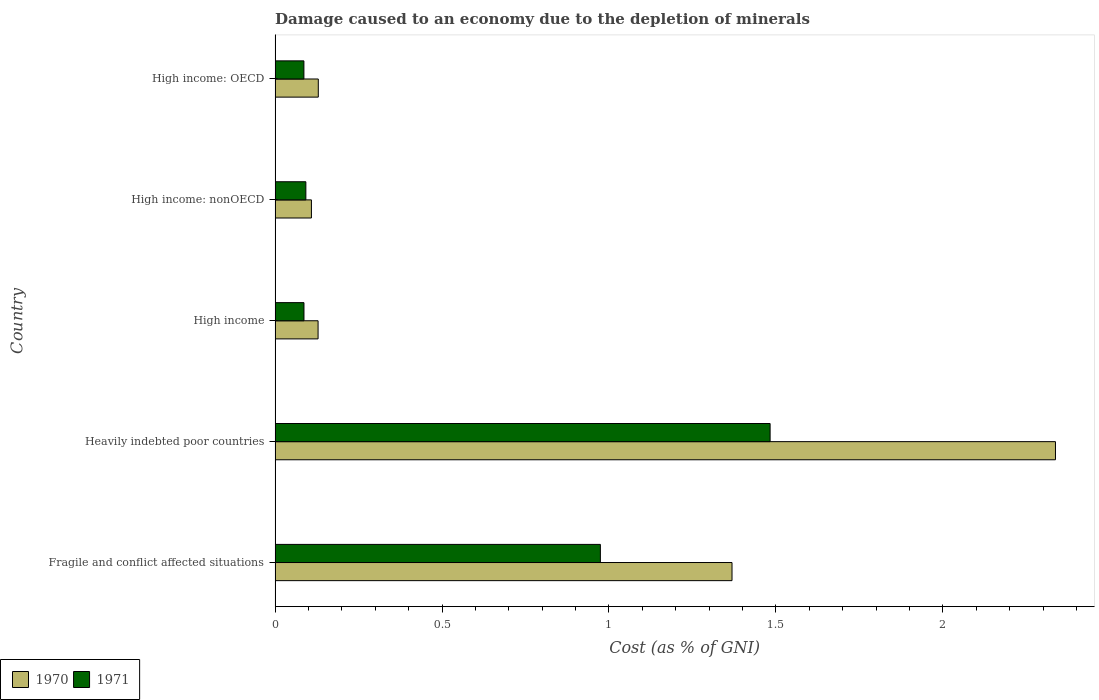How many groups of bars are there?
Provide a short and direct response. 5. Are the number of bars per tick equal to the number of legend labels?
Keep it short and to the point. Yes. Are the number of bars on each tick of the Y-axis equal?
Your answer should be very brief. Yes. How many bars are there on the 1st tick from the bottom?
Your answer should be compact. 2. What is the cost of damage caused due to the depletion of minerals in 1971 in High income: OECD?
Provide a short and direct response. 0.09. Across all countries, what is the maximum cost of damage caused due to the depletion of minerals in 1970?
Provide a short and direct response. 2.34. Across all countries, what is the minimum cost of damage caused due to the depletion of minerals in 1970?
Offer a terse response. 0.11. In which country was the cost of damage caused due to the depletion of minerals in 1971 maximum?
Offer a very short reply. Heavily indebted poor countries. In which country was the cost of damage caused due to the depletion of minerals in 1970 minimum?
Offer a terse response. High income: nonOECD. What is the total cost of damage caused due to the depletion of minerals in 1971 in the graph?
Make the answer very short. 2.72. What is the difference between the cost of damage caused due to the depletion of minerals in 1971 in Heavily indebted poor countries and that in High income: nonOECD?
Offer a very short reply. 1.39. What is the difference between the cost of damage caused due to the depletion of minerals in 1970 in High income: nonOECD and the cost of damage caused due to the depletion of minerals in 1971 in High income: OECD?
Provide a succinct answer. 0.02. What is the average cost of damage caused due to the depletion of minerals in 1971 per country?
Make the answer very short. 0.54. What is the difference between the cost of damage caused due to the depletion of minerals in 1971 and cost of damage caused due to the depletion of minerals in 1970 in High income: OECD?
Your response must be concise. -0.04. In how many countries, is the cost of damage caused due to the depletion of minerals in 1970 greater than 1.3 %?
Provide a short and direct response. 2. What is the ratio of the cost of damage caused due to the depletion of minerals in 1970 in Fragile and conflict affected situations to that in High income?
Your response must be concise. 10.63. Is the cost of damage caused due to the depletion of minerals in 1970 in High income less than that in High income: OECD?
Your answer should be very brief. Yes. What is the difference between the highest and the second highest cost of damage caused due to the depletion of minerals in 1970?
Give a very brief answer. 0.97. What is the difference between the highest and the lowest cost of damage caused due to the depletion of minerals in 1971?
Your answer should be very brief. 1.4. In how many countries, is the cost of damage caused due to the depletion of minerals in 1971 greater than the average cost of damage caused due to the depletion of minerals in 1971 taken over all countries?
Give a very brief answer. 2. Is the sum of the cost of damage caused due to the depletion of minerals in 1971 in Fragile and conflict affected situations and High income greater than the maximum cost of damage caused due to the depletion of minerals in 1970 across all countries?
Provide a succinct answer. No. Are all the bars in the graph horizontal?
Your response must be concise. Yes. What is the difference between two consecutive major ticks on the X-axis?
Give a very brief answer. 0.5. Are the values on the major ticks of X-axis written in scientific E-notation?
Keep it short and to the point. No. Does the graph contain grids?
Your answer should be compact. No. How are the legend labels stacked?
Keep it short and to the point. Horizontal. What is the title of the graph?
Offer a terse response. Damage caused to an economy due to the depletion of minerals. What is the label or title of the X-axis?
Ensure brevity in your answer.  Cost (as % of GNI). What is the Cost (as % of GNI) of 1970 in Fragile and conflict affected situations?
Offer a very short reply. 1.37. What is the Cost (as % of GNI) in 1971 in Fragile and conflict affected situations?
Your answer should be compact. 0.97. What is the Cost (as % of GNI) of 1970 in Heavily indebted poor countries?
Your answer should be compact. 2.34. What is the Cost (as % of GNI) in 1971 in Heavily indebted poor countries?
Give a very brief answer. 1.48. What is the Cost (as % of GNI) in 1970 in High income?
Your answer should be very brief. 0.13. What is the Cost (as % of GNI) of 1971 in High income?
Keep it short and to the point. 0.09. What is the Cost (as % of GNI) of 1970 in High income: nonOECD?
Provide a succinct answer. 0.11. What is the Cost (as % of GNI) of 1971 in High income: nonOECD?
Offer a terse response. 0.09. What is the Cost (as % of GNI) in 1970 in High income: OECD?
Provide a succinct answer. 0.13. What is the Cost (as % of GNI) of 1971 in High income: OECD?
Provide a succinct answer. 0.09. Across all countries, what is the maximum Cost (as % of GNI) of 1970?
Provide a succinct answer. 2.34. Across all countries, what is the maximum Cost (as % of GNI) of 1971?
Your answer should be very brief. 1.48. Across all countries, what is the minimum Cost (as % of GNI) of 1970?
Your response must be concise. 0.11. Across all countries, what is the minimum Cost (as % of GNI) in 1971?
Provide a short and direct response. 0.09. What is the total Cost (as % of GNI) of 1970 in the graph?
Provide a short and direct response. 4.07. What is the total Cost (as % of GNI) in 1971 in the graph?
Your answer should be very brief. 2.72. What is the difference between the Cost (as % of GNI) in 1970 in Fragile and conflict affected situations and that in Heavily indebted poor countries?
Offer a terse response. -0.97. What is the difference between the Cost (as % of GNI) of 1971 in Fragile and conflict affected situations and that in Heavily indebted poor countries?
Offer a terse response. -0.51. What is the difference between the Cost (as % of GNI) of 1970 in Fragile and conflict affected situations and that in High income?
Make the answer very short. 1.24. What is the difference between the Cost (as % of GNI) of 1971 in Fragile and conflict affected situations and that in High income?
Offer a very short reply. 0.89. What is the difference between the Cost (as % of GNI) in 1970 in Fragile and conflict affected situations and that in High income: nonOECD?
Ensure brevity in your answer.  1.26. What is the difference between the Cost (as % of GNI) in 1971 in Fragile and conflict affected situations and that in High income: nonOECD?
Ensure brevity in your answer.  0.88. What is the difference between the Cost (as % of GNI) in 1970 in Fragile and conflict affected situations and that in High income: OECD?
Keep it short and to the point. 1.24. What is the difference between the Cost (as % of GNI) in 1971 in Fragile and conflict affected situations and that in High income: OECD?
Give a very brief answer. 0.89. What is the difference between the Cost (as % of GNI) in 1970 in Heavily indebted poor countries and that in High income?
Provide a short and direct response. 2.21. What is the difference between the Cost (as % of GNI) of 1971 in Heavily indebted poor countries and that in High income?
Your response must be concise. 1.4. What is the difference between the Cost (as % of GNI) in 1970 in Heavily indebted poor countries and that in High income: nonOECD?
Your answer should be compact. 2.23. What is the difference between the Cost (as % of GNI) in 1971 in Heavily indebted poor countries and that in High income: nonOECD?
Keep it short and to the point. 1.39. What is the difference between the Cost (as % of GNI) in 1970 in Heavily indebted poor countries and that in High income: OECD?
Offer a terse response. 2.21. What is the difference between the Cost (as % of GNI) of 1971 in Heavily indebted poor countries and that in High income: OECD?
Your answer should be very brief. 1.4. What is the difference between the Cost (as % of GNI) of 1971 in High income and that in High income: nonOECD?
Offer a terse response. -0.01. What is the difference between the Cost (as % of GNI) in 1970 in High income and that in High income: OECD?
Your response must be concise. -0. What is the difference between the Cost (as % of GNI) of 1970 in High income: nonOECD and that in High income: OECD?
Give a very brief answer. -0.02. What is the difference between the Cost (as % of GNI) of 1971 in High income: nonOECD and that in High income: OECD?
Give a very brief answer. 0.01. What is the difference between the Cost (as % of GNI) in 1970 in Fragile and conflict affected situations and the Cost (as % of GNI) in 1971 in Heavily indebted poor countries?
Keep it short and to the point. -0.11. What is the difference between the Cost (as % of GNI) in 1970 in Fragile and conflict affected situations and the Cost (as % of GNI) in 1971 in High income?
Provide a short and direct response. 1.28. What is the difference between the Cost (as % of GNI) of 1970 in Fragile and conflict affected situations and the Cost (as % of GNI) of 1971 in High income: nonOECD?
Ensure brevity in your answer.  1.28. What is the difference between the Cost (as % of GNI) in 1970 in Fragile and conflict affected situations and the Cost (as % of GNI) in 1971 in High income: OECD?
Make the answer very short. 1.28. What is the difference between the Cost (as % of GNI) of 1970 in Heavily indebted poor countries and the Cost (as % of GNI) of 1971 in High income?
Your response must be concise. 2.25. What is the difference between the Cost (as % of GNI) of 1970 in Heavily indebted poor countries and the Cost (as % of GNI) of 1971 in High income: nonOECD?
Ensure brevity in your answer.  2.25. What is the difference between the Cost (as % of GNI) of 1970 in Heavily indebted poor countries and the Cost (as % of GNI) of 1971 in High income: OECD?
Provide a succinct answer. 2.25. What is the difference between the Cost (as % of GNI) of 1970 in High income and the Cost (as % of GNI) of 1971 in High income: nonOECD?
Keep it short and to the point. 0.04. What is the difference between the Cost (as % of GNI) in 1970 in High income and the Cost (as % of GNI) in 1971 in High income: OECD?
Your answer should be compact. 0.04. What is the difference between the Cost (as % of GNI) in 1970 in High income: nonOECD and the Cost (as % of GNI) in 1971 in High income: OECD?
Give a very brief answer. 0.02. What is the average Cost (as % of GNI) of 1970 per country?
Your answer should be compact. 0.81. What is the average Cost (as % of GNI) of 1971 per country?
Keep it short and to the point. 0.54. What is the difference between the Cost (as % of GNI) in 1970 and Cost (as % of GNI) in 1971 in Fragile and conflict affected situations?
Provide a succinct answer. 0.39. What is the difference between the Cost (as % of GNI) of 1970 and Cost (as % of GNI) of 1971 in Heavily indebted poor countries?
Keep it short and to the point. 0.85. What is the difference between the Cost (as % of GNI) of 1970 and Cost (as % of GNI) of 1971 in High income?
Give a very brief answer. 0.04. What is the difference between the Cost (as % of GNI) of 1970 and Cost (as % of GNI) of 1971 in High income: nonOECD?
Give a very brief answer. 0.02. What is the difference between the Cost (as % of GNI) of 1970 and Cost (as % of GNI) of 1971 in High income: OECD?
Ensure brevity in your answer.  0.04. What is the ratio of the Cost (as % of GNI) of 1970 in Fragile and conflict affected situations to that in Heavily indebted poor countries?
Your response must be concise. 0.59. What is the ratio of the Cost (as % of GNI) in 1971 in Fragile and conflict affected situations to that in Heavily indebted poor countries?
Offer a terse response. 0.66. What is the ratio of the Cost (as % of GNI) in 1970 in Fragile and conflict affected situations to that in High income?
Your answer should be very brief. 10.63. What is the ratio of the Cost (as % of GNI) in 1971 in Fragile and conflict affected situations to that in High income?
Ensure brevity in your answer.  11.26. What is the ratio of the Cost (as % of GNI) in 1970 in Fragile and conflict affected situations to that in High income: nonOECD?
Provide a short and direct response. 12.57. What is the ratio of the Cost (as % of GNI) of 1971 in Fragile and conflict affected situations to that in High income: nonOECD?
Your answer should be very brief. 10.57. What is the ratio of the Cost (as % of GNI) of 1970 in Fragile and conflict affected situations to that in High income: OECD?
Provide a short and direct response. 10.57. What is the ratio of the Cost (as % of GNI) of 1971 in Fragile and conflict affected situations to that in High income: OECD?
Give a very brief answer. 11.28. What is the ratio of the Cost (as % of GNI) in 1970 in Heavily indebted poor countries to that in High income?
Your response must be concise. 18.15. What is the ratio of the Cost (as % of GNI) of 1971 in Heavily indebted poor countries to that in High income?
Make the answer very short. 17.13. What is the ratio of the Cost (as % of GNI) of 1970 in Heavily indebted poor countries to that in High income: nonOECD?
Give a very brief answer. 21.48. What is the ratio of the Cost (as % of GNI) in 1971 in Heavily indebted poor countries to that in High income: nonOECD?
Provide a short and direct response. 16.08. What is the ratio of the Cost (as % of GNI) in 1970 in Heavily indebted poor countries to that in High income: OECD?
Your answer should be compact. 18.06. What is the ratio of the Cost (as % of GNI) in 1971 in Heavily indebted poor countries to that in High income: OECD?
Your answer should be compact. 17.17. What is the ratio of the Cost (as % of GNI) in 1970 in High income to that in High income: nonOECD?
Offer a terse response. 1.18. What is the ratio of the Cost (as % of GNI) in 1971 in High income to that in High income: nonOECD?
Your response must be concise. 0.94. What is the ratio of the Cost (as % of GNI) in 1970 in High income to that in High income: OECD?
Offer a very short reply. 1. What is the ratio of the Cost (as % of GNI) of 1971 in High income to that in High income: OECD?
Your answer should be compact. 1. What is the ratio of the Cost (as % of GNI) in 1970 in High income: nonOECD to that in High income: OECD?
Keep it short and to the point. 0.84. What is the ratio of the Cost (as % of GNI) of 1971 in High income: nonOECD to that in High income: OECD?
Offer a terse response. 1.07. What is the difference between the highest and the second highest Cost (as % of GNI) in 1970?
Offer a very short reply. 0.97. What is the difference between the highest and the second highest Cost (as % of GNI) of 1971?
Provide a succinct answer. 0.51. What is the difference between the highest and the lowest Cost (as % of GNI) of 1970?
Your response must be concise. 2.23. What is the difference between the highest and the lowest Cost (as % of GNI) of 1971?
Provide a short and direct response. 1.4. 